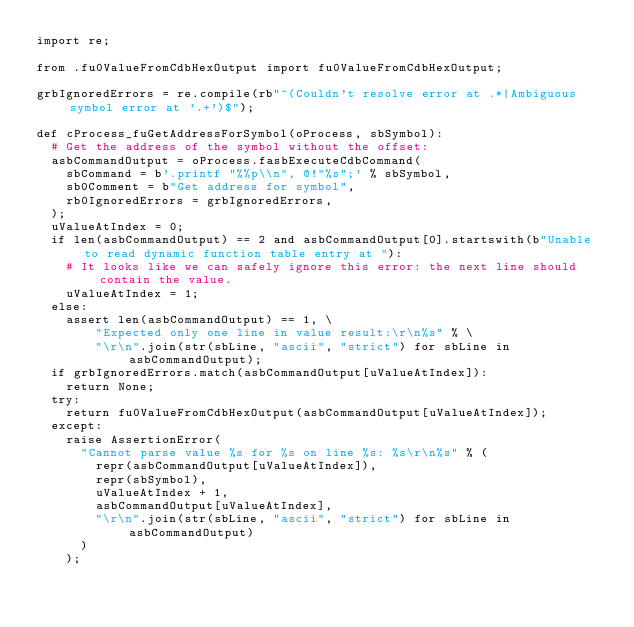Convert code to text. <code><loc_0><loc_0><loc_500><loc_500><_Python_>import re;

from .fu0ValueFromCdbHexOutput import fu0ValueFromCdbHexOutput;

grbIgnoredErrors = re.compile(rb"^(Couldn't resolve error at .*|Ambiguous symbol error at '.+')$");

def cProcess_fuGetAddressForSymbol(oProcess, sbSymbol):
  # Get the address of the symbol without the offset:
  asbCommandOutput = oProcess.fasbExecuteCdbCommand(
    sbCommand = b'.printf "%%p\\n", @!"%s";' % sbSymbol,
    sb0Comment = b"Get address for symbol",
    rb0IgnoredErrors = grbIgnoredErrors,
  );
  uValueAtIndex = 0;
  if len(asbCommandOutput) == 2 and asbCommandOutput[0].startswith(b"Unable to read dynamic function table entry at "):
    # It looks like we can safely ignore this error: the next line should contain the value.
    uValueAtIndex = 1;
  else:
    assert len(asbCommandOutput) == 1, \
        "Expected only one line in value result:\r\n%s" % \
        "\r\n".join(str(sbLine, "ascii", "strict") for sbLine in asbCommandOutput);
  if grbIgnoredErrors.match(asbCommandOutput[uValueAtIndex]):
    return None;
  try:
    return fu0ValueFromCdbHexOutput(asbCommandOutput[uValueAtIndex]);
  except:
    raise AssertionError(
      "Cannot parse value %s for %s on line %s: %s\r\n%s" % (
        repr(asbCommandOutput[uValueAtIndex]),
        repr(sbSymbol),
        uValueAtIndex + 1,
        asbCommandOutput[uValueAtIndex],
        "\r\n".join(str(sbLine, "ascii", "strict") for sbLine in asbCommandOutput)
      )
    );
</code> 